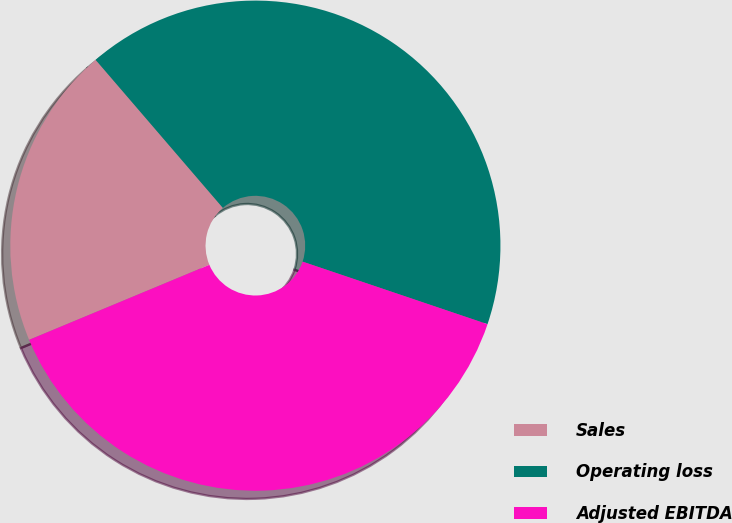Convert chart to OTSL. <chart><loc_0><loc_0><loc_500><loc_500><pie_chart><fcel>Sales<fcel>Operating loss<fcel>Adjusted EBITDA<nl><fcel>19.98%<fcel>41.49%<fcel>38.53%<nl></chart> 